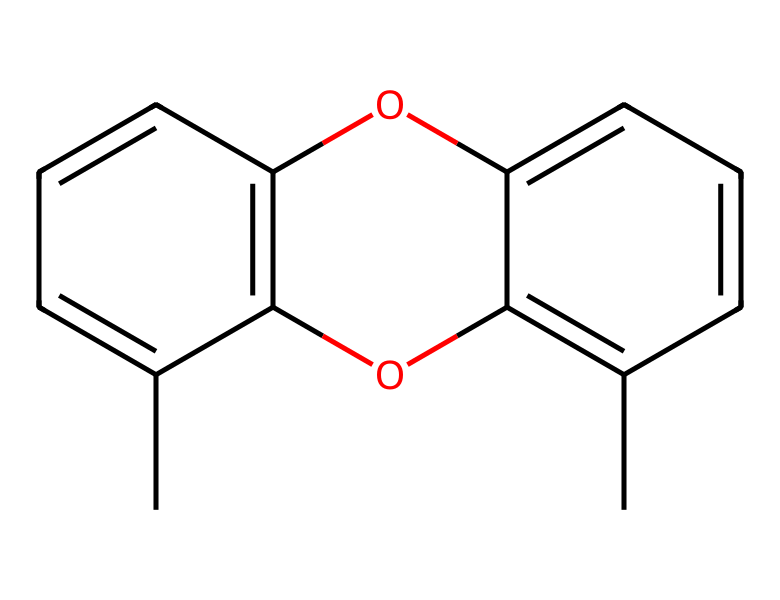how many carbon atoms are in this chemical? The chemical structure shows several 'C' symbols representing carbon atoms. By counting the carbons within the structure, there are 15 carbon atoms in total.
Answer: 15 how many oxygen atoms are in this chemical? The structure contains 'O' symbols indicating the presence of oxygen atoms. Counting these, we find there are 2 oxygen atoms in the molecule.
Answer: 2 what functional groups are present in this compound? Upon examining the chemical structure, we can identify hydroxyl (-OH) groups from the 'O' connected to carbon atoms. This indicates the presence of phenolic functional groups.
Answer: phenolic is this compound aromatic? The structure shows a cyclic arrangement of carbon atoms with alternating double bonds, which is characteristic of aromatic compounds due to the delocalization of electrons.
Answer: yes how many rings are in this molecule? The molecular structure contains interconnected carbon atoms that form closed loops. By analyzing the structure, it is observed that there are 2 rings present in the molecule.
Answer: 2 what is the primary use of this chemical? This chemical is a common component in wood preservatives typically utilized to protect wooden structures, particularly in aquatic environments like fishing boats due to its water-repelling properties.
Answer: wood preservative which type of bond connects the oxygen atoms to the carbon atoms? The structure shows that the oxygen atoms are connected to the carbon atoms through single bonds, which are represented by the lines in the structure between 'O' and 'C'.
Answer: single bonds 